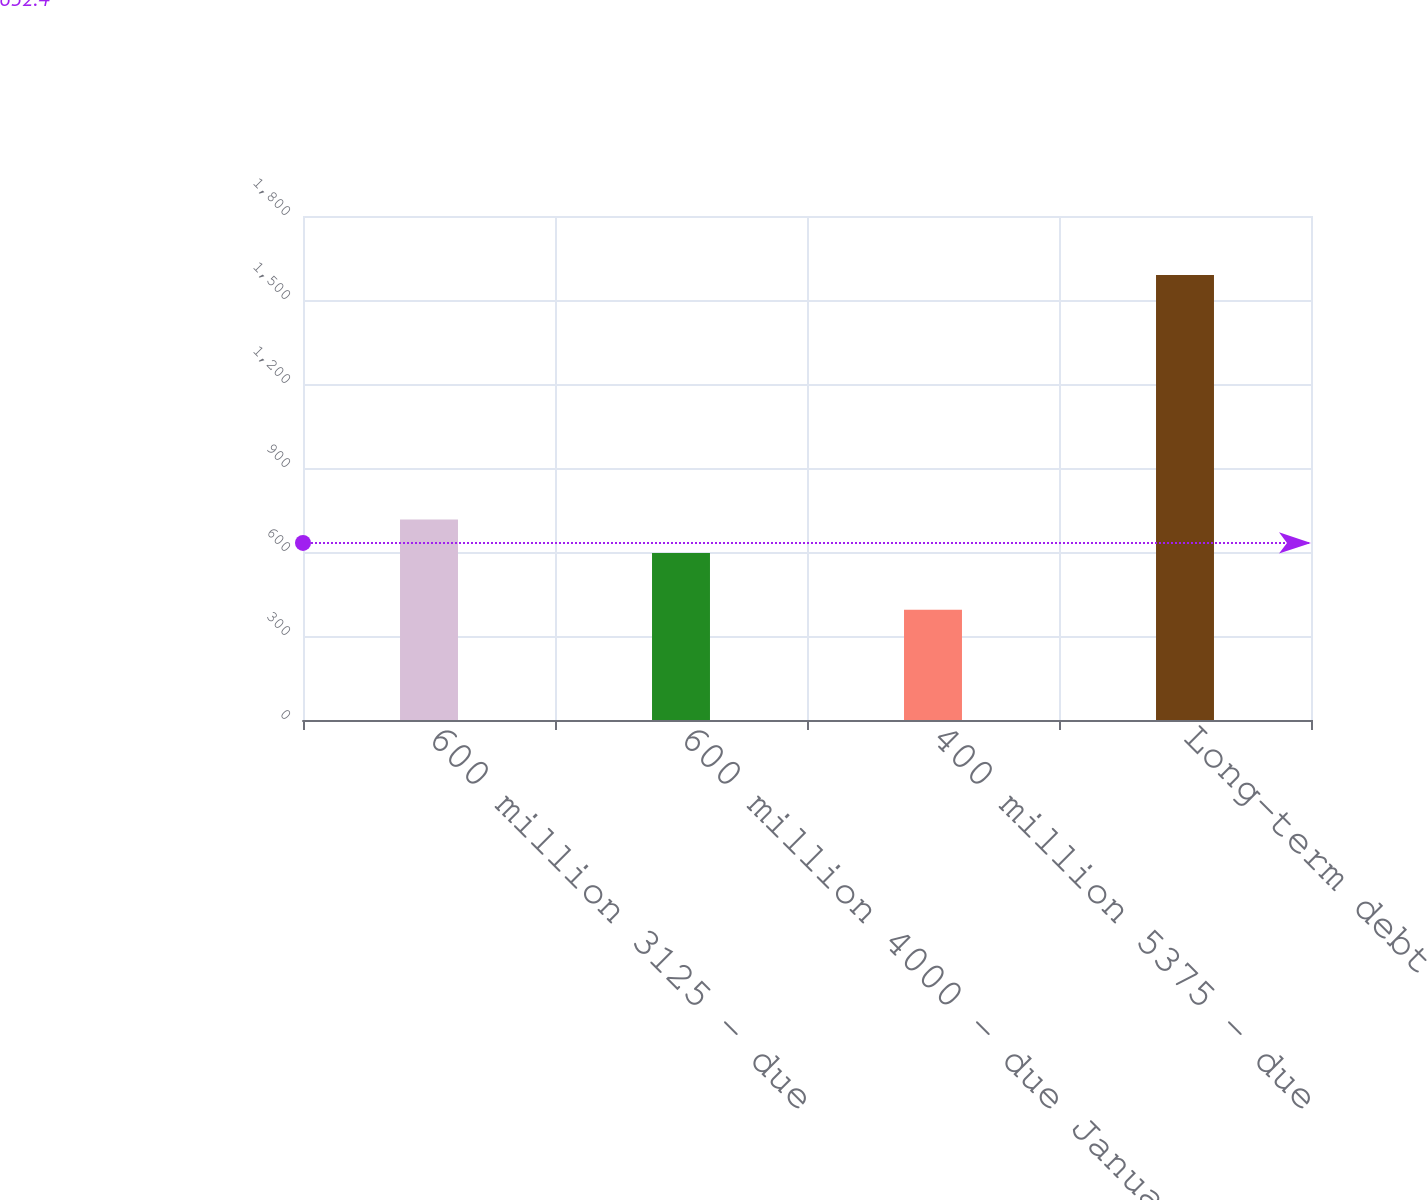Convert chart. <chart><loc_0><loc_0><loc_500><loc_500><bar_chart><fcel>600 million 3125 - due<fcel>600 million 4000 - due January<fcel>400 million 5375 - due<fcel>Long-term debt<nl><fcel>715.78<fcel>596.2<fcel>393.5<fcel>1589.3<nl></chart> 